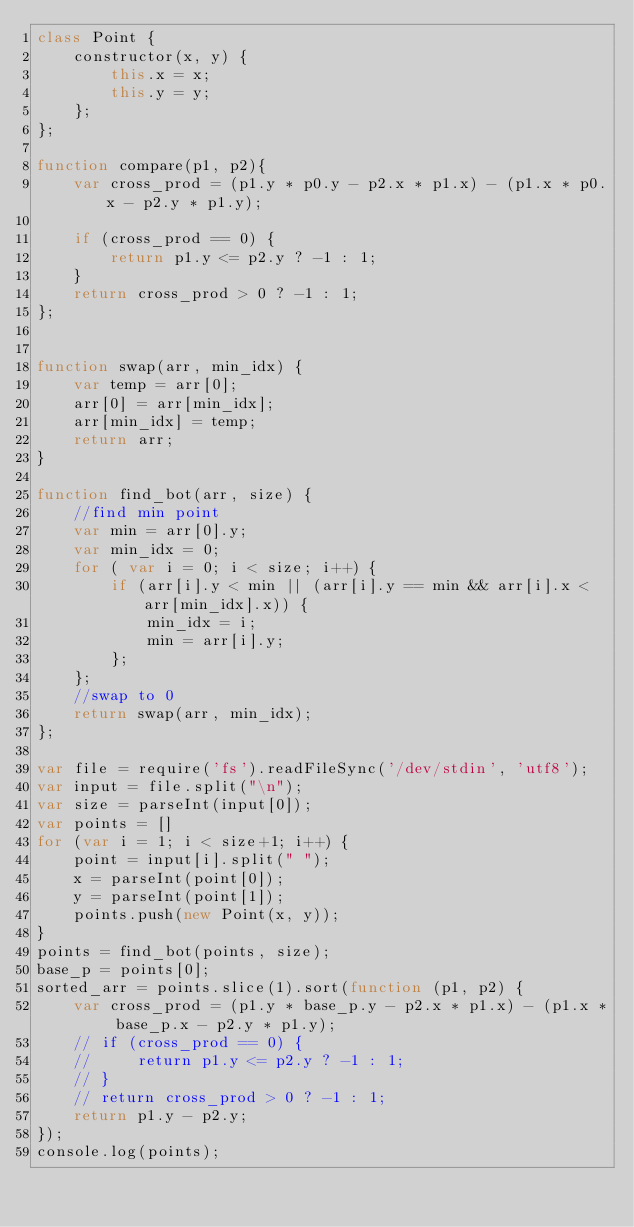<code> <loc_0><loc_0><loc_500><loc_500><_JavaScript_>class Point {
    constructor(x, y) {
        this.x = x;
        this.y = y;
    };
};

function compare(p1, p2){
    var cross_prod = (p1.y * p0.y - p2.x * p1.x) - (p1.x * p0.x - p2.y * p1.y);

    if (cross_prod == 0) {
        return p1.y <= p2.y ? -1 : 1;
    }
    return cross_prod > 0 ? -1 : 1;
};


function swap(arr, min_idx) {
    var temp = arr[0];
    arr[0] = arr[min_idx];
    arr[min_idx] = temp;
    return arr;
}

function find_bot(arr, size) {
    //find min point
    var min = arr[0].y;
    var min_idx = 0;
    for ( var i = 0; i < size; i++) {
        if (arr[i].y < min || (arr[i].y == min && arr[i].x < arr[min_idx].x)) {
            min_idx = i;
            min = arr[i].y;
        };
    };
    //swap to 0
    return swap(arr, min_idx);
};

var file = require('fs').readFileSync('/dev/stdin', 'utf8');
var input = file.split("\n");
var size = parseInt(input[0]);
var points = []
for (var i = 1; i < size+1; i++) {
    point = input[i].split(" ");
    x = parseInt(point[0]);
    y = parseInt(point[1]);
    points.push(new Point(x, y));
}
points = find_bot(points, size);
base_p = points[0];
sorted_arr = points.slice(1).sort(function (p1, p2) {
    var cross_prod = (p1.y * base_p.y - p2.x * p1.x) - (p1.x * base_p.x - p2.y * p1.y);
    // if (cross_prod == 0) {
    //     return p1.y <= p2.y ? -1 : 1;
    // }
    // return cross_prod > 0 ? -1 : 1;
    return p1.y - p2.y;
});
console.log(points);



</code> 